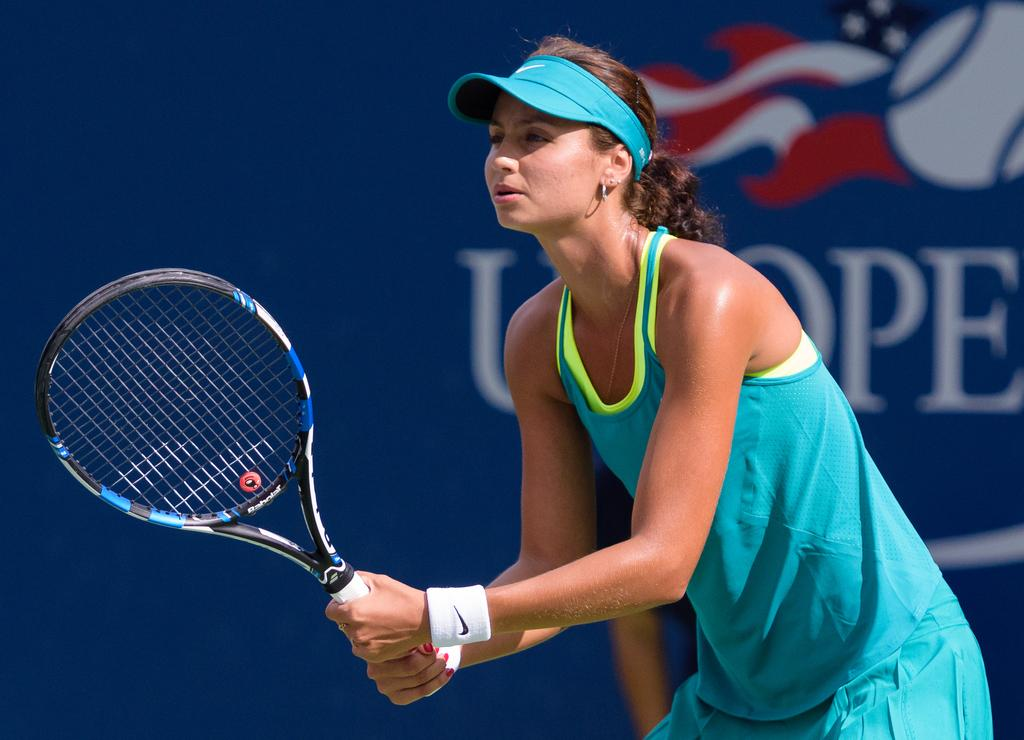What is the gender of the player in the image? The player in the image is a female. What object is the female player holding? The female player is holding a tennis bat. What can be seen in the background of the image? There is a blue color banner in the background of the image. What is written on the banner? The banner has text on it. Can you see a cat playing with a rifle in the image? No, there is no cat or rifle present in the image. 